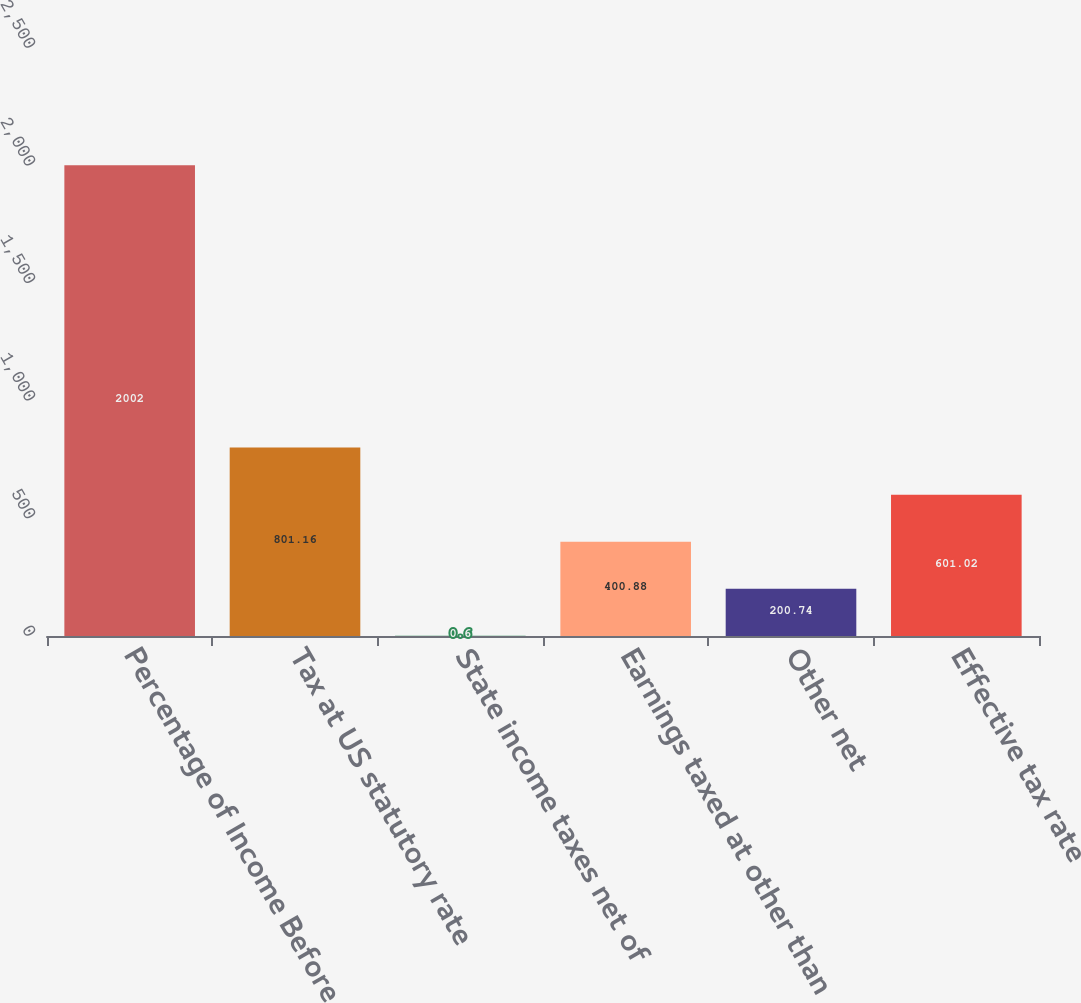Convert chart. <chart><loc_0><loc_0><loc_500><loc_500><bar_chart><fcel>Percentage of Income Before<fcel>Tax at US statutory rate<fcel>State income taxes net of<fcel>Earnings taxed at other than<fcel>Other net<fcel>Effective tax rate<nl><fcel>2002<fcel>801.16<fcel>0.6<fcel>400.88<fcel>200.74<fcel>601.02<nl></chart> 